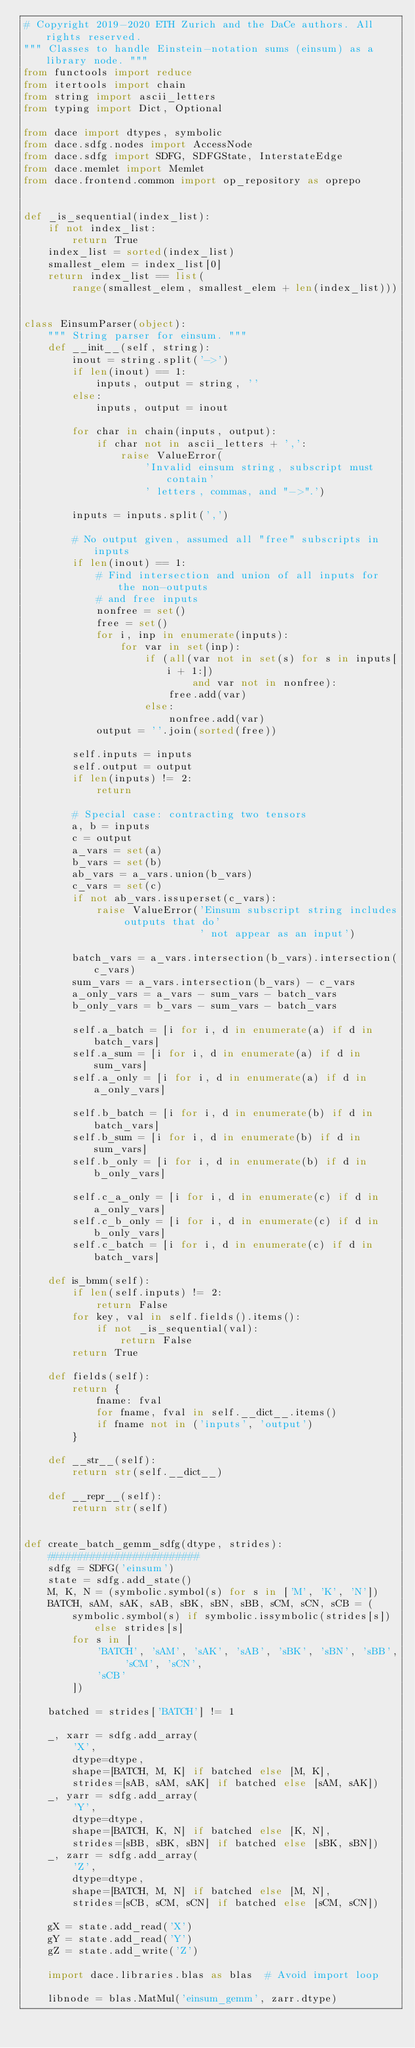<code> <loc_0><loc_0><loc_500><loc_500><_Python_># Copyright 2019-2020 ETH Zurich and the DaCe authors. All rights reserved.
""" Classes to handle Einstein-notation sums (einsum) as a library node. """
from functools import reduce
from itertools import chain
from string import ascii_letters
from typing import Dict, Optional

from dace import dtypes, symbolic
from dace.sdfg.nodes import AccessNode
from dace.sdfg import SDFG, SDFGState, InterstateEdge
from dace.memlet import Memlet
from dace.frontend.common import op_repository as oprepo


def _is_sequential(index_list):
    if not index_list:
        return True
    index_list = sorted(index_list)
    smallest_elem = index_list[0]
    return index_list == list(
        range(smallest_elem, smallest_elem + len(index_list)))


class EinsumParser(object):
    """ String parser for einsum. """
    def __init__(self, string):
        inout = string.split('->')
        if len(inout) == 1:
            inputs, output = string, ''
        else:
            inputs, output = inout

        for char in chain(inputs, output):
            if char not in ascii_letters + ',':
                raise ValueError(
                    'Invalid einsum string, subscript must contain'
                    ' letters, commas, and "->".')

        inputs = inputs.split(',')

        # No output given, assumed all "free" subscripts in inputs
        if len(inout) == 1:
            # Find intersection and union of all inputs for the non-outputs
            # and free inputs
            nonfree = set()
            free = set()
            for i, inp in enumerate(inputs):
                for var in set(inp):
                    if (all(var not in set(s) for s in inputs[i + 1:])
                            and var not in nonfree):
                        free.add(var)
                    else:
                        nonfree.add(var)
            output = ''.join(sorted(free))

        self.inputs = inputs
        self.output = output
        if len(inputs) != 2:
            return

        # Special case: contracting two tensors
        a, b = inputs
        c = output
        a_vars = set(a)
        b_vars = set(b)
        ab_vars = a_vars.union(b_vars)
        c_vars = set(c)
        if not ab_vars.issuperset(c_vars):
            raise ValueError('Einsum subscript string includes outputs that do'
                             ' not appear as an input')

        batch_vars = a_vars.intersection(b_vars).intersection(c_vars)
        sum_vars = a_vars.intersection(b_vars) - c_vars
        a_only_vars = a_vars - sum_vars - batch_vars
        b_only_vars = b_vars - sum_vars - batch_vars

        self.a_batch = [i for i, d in enumerate(a) if d in batch_vars]
        self.a_sum = [i for i, d in enumerate(a) if d in sum_vars]
        self.a_only = [i for i, d in enumerate(a) if d in a_only_vars]

        self.b_batch = [i for i, d in enumerate(b) if d in batch_vars]
        self.b_sum = [i for i, d in enumerate(b) if d in sum_vars]
        self.b_only = [i for i, d in enumerate(b) if d in b_only_vars]

        self.c_a_only = [i for i, d in enumerate(c) if d in a_only_vars]
        self.c_b_only = [i for i, d in enumerate(c) if d in b_only_vars]
        self.c_batch = [i for i, d in enumerate(c) if d in batch_vars]

    def is_bmm(self):
        if len(self.inputs) != 2:
            return False
        for key, val in self.fields().items():
            if not _is_sequential(val):
                return False
        return True

    def fields(self):
        return {
            fname: fval
            for fname, fval in self.__dict__.items()
            if fname not in ('inputs', 'output')
        }

    def __str__(self):
        return str(self.__dict__)

    def __repr__(self):
        return str(self)


def create_batch_gemm_sdfg(dtype, strides):
    #########################
    sdfg = SDFG('einsum')
    state = sdfg.add_state()
    M, K, N = (symbolic.symbol(s) for s in ['M', 'K', 'N'])
    BATCH, sAM, sAK, sAB, sBK, sBN, sBB, sCM, sCN, sCB = (
        symbolic.symbol(s) if symbolic.issymbolic(strides[s]) else strides[s]
        for s in [
            'BATCH', 'sAM', 'sAK', 'sAB', 'sBK', 'sBN', 'sBB', 'sCM', 'sCN',
            'sCB'
        ])

    batched = strides['BATCH'] != 1

    _, xarr = sdfg.add_array(
        'X',
        dtype=dtype,
        shape=[BATCH, M, K] if batched else [M, K],
        strides=[sAB, sAM, sAK] if batched else [sAM, sAK])
    _, yarr = sdfg.add_array(
        'Y',
        dtype=dtype,
        shape=[BATCH, K, N] if batched else [K, N],
        strides=[sBB, sBK, sBN] if batched else [sBK, sBN])
    _, zarr = sdfg.add_array(
        'Z',
        dtype=dtype,
        shape=[BATCH, M, N] if batched else [M, N],
        strides=[sCB, sCM, sCN] if batched else [sCM, sCN])

    gX = state.add_read('X')
    gY = state.add_read('Y')
    gZ = state.add_write('Z')

    import dace.libraries.blas as blas  # Avoid import loop

    libnode = blas.MatMul('einsum_gemm', zarr.dtype)</code> 